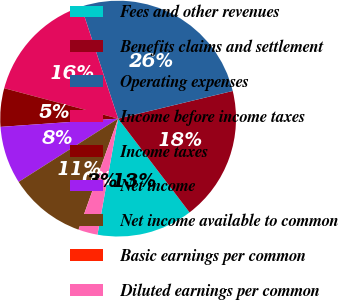Convert chart. <chart><loc_0><loc_0><loc_500><loc_500><pie_chart><fcel>Fees and other revenues<fcel>Benefits claims and settlement<fcel>Operating expenses<fcel>Income before income taxes<fcel>Income taxes<fcel>Net income<fcel>Net income available to common<fcel>Basic earnings per common<fcel>Diluted earnings per common<nl><fcel>13.16%<fcel>18.41%<fcel>26.3%<fcel>15.78%<fcel>5.27%<fcel>7.9%<fcel>10.53%<fcel>0.01%<fcel>2.64%<nl></chart> 